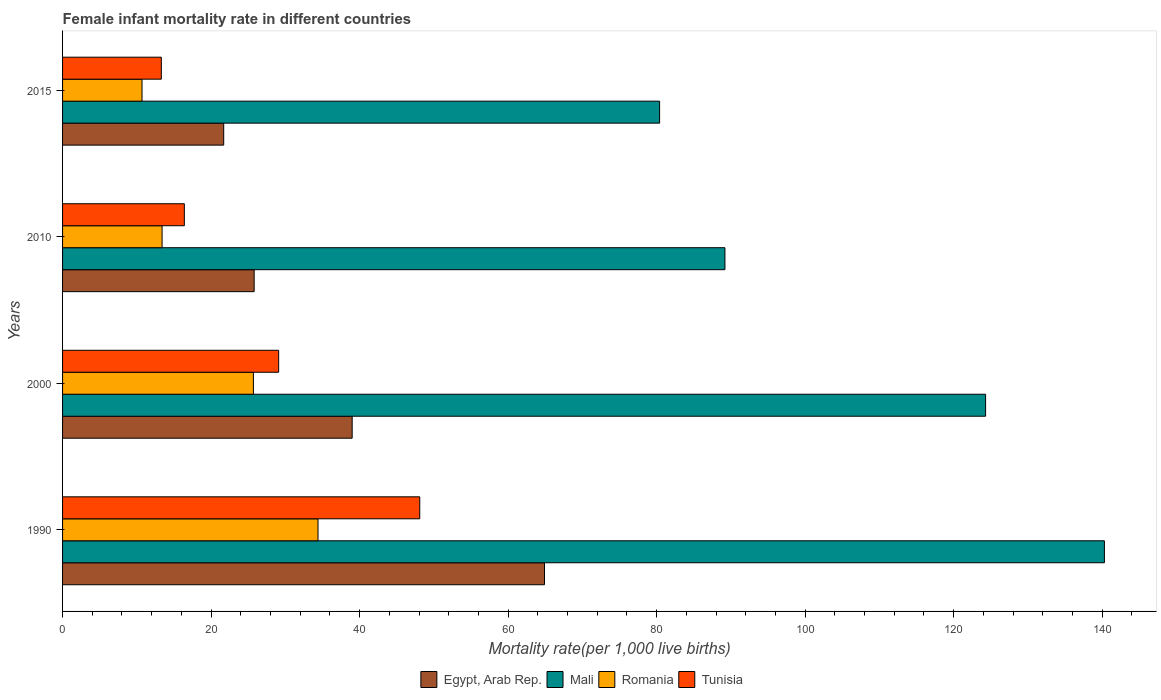How many different coloured bars are there?
Offer a very short reply. 4. How many groups of bars are there?
Your answer should be very brief. 4. Are the number of bars per tick equal to the number of legend labels?
Offer a terse response. Yes. Are the number of bars on each tick of the Y-axis equal?
Offer a very short reply. Yes. How many bars are there on the 4th tick from the top?
Provide a short and direct response. 4. How many bars are there on the 2nd tick from the bottom?
Offer a terse response. 4. What is the female infant mortality rate in Egypt, Arab Rep. in 2015?
Ensure brevity in your answer.  21.7. Across all years, what is the maximum female infant mortality rate in Egypt, Arab Rep.?
Provide a short and direct response. 64.9. Across all years, what is the minimum female infant mortality rate in Egypt, Arab Rep.?
Your answer should be very brief. 21.7. In which year was the female infant mortality rate in Romania maximum?
Offer a very short reply. 1990. In which year was the female infant mortality rate in Mali minimum?
Offer a terse response. 2015. What is the total female infant mortality rate in Egypt, Arab Rep. in the graph?
Offer a terse response. 151.4. What is the difference between the female infant mortality rate in Romania in 2010 and the female infant mortality rate in Egypt, Arab Rep. in 2015?
Keep it short and to the point. -8.3. What is the average female infant mortality rate in Romania per year?
Offer a very short reply. 21.05. What is the ratio of the female infant mortality rate in Mali in 1990 to that in 2000?
Ensure brevity in your answer.  1.13. Is the difference between the female infant mortality rate in Romania in 1990 and 2000 greater than the difference between the female infant mortality rate in Egypt, Arab Rep. in 1990 and 2000?
Offer a terse response. No. What is the difference between the highest and the second highest female infant mortality rate in Egypt, Arab Rep.?
Make the answer very short. 25.9. What is the difference between the highest and the lowest female infant mortality rate in Tunisia?
Ensure brevity in your answer.  34.8. Is the sum of the female infant mortality rate in Romania in 2000 and 2010 greater than the maximum female infant mortality rate in Egypt, Arab Rep. across all years?
Keep it short and to the point. No. Is it the case that in every year, the sum of the female infant mortality rate in Tunisia and female infant mortality rate in Romania is greater than the sum of female infant mortality rate in Mali and female infant mortality rate in Egypt, Arab Rep.?
Provide a succinct answer. No. What does the 2nd bar from the top in 2015 represents?
Your response must be concise. Romania. What does the 1st bar from the bottom in 2000 represents?
Keep it short and to the point. Egypt, Arab Rep. Is it the case that in every year, the sum of the female infant mortality rate in Mali and female infant mortality rate in Romania is greater than the female infant mortality rate in Tunisia?
Make the answer very short. Yes. How many years are there in the graph?
Your response must be concise. 4. What is the difference between two consecutive major ticks on the X-axis?
Provide a succinct answer. 20. Are the values on the major ticks of X-axis written in scientific E-notation?
Offer a very short reply. No. Does the graph contain any zero values?
Your answer should be very brief. No. How many legend labels are there?
Provide a succinct answer. 4. What is the title of the graph?
Provide a short and direct response. Female infant mortality rate in different countries. Does "Bangladesh" appear as one of the legend labels in the graph?
Ensure brevity in your answer.  No. What is the label or title of the X-axis?
Your answer should be very brief. Mortality rate(per 1,0 live births). What is the label or title of the Y-axis?
Make the answer very short. Years. What is the Mortality rate(per 1,000 live births) in Egypt, Arab Rep. in 1990?
Provide a short and direct response. 64.9. What is the Mortality rate(per 1,000 live births) of Mali in 1990?
Provide a short and direct response. 140.3. What is the Mortality rate(per 1,000 live births) of Romania in 1990?
Make the answer very short. 34.4. What is the Mortality rate(per 1,000 live births) in Tunisia in 1990?
Provide a succinct answer. 48.1. What is the Mortality rate(per 1,000 live births) in Egypt, Arab Rep. in 2000?
Offer a very short reply. 39. What is the Mortality rate(per 1,000 live births) in Mali in 2000?
Offer a very short reply. 124.3. What is the Mortality rate(per 1,000 live births) in Romania in 2000?
Provide a succinct answer. 25.7. What is the Mortality rate(per 1,000 live births) of Tunisia in 2000?
Give a very brief answer. 29.1. What is the Mortality rate(per 1,000 live births) of Egypt, Arab Rep. in 2010?
Offer a terse response. 25.8. What is the Mortality rate(per 1,000 live births) of Mali in 2010?
Keep it short and to the point. 89.2. What is the Mortality rate(per 1,000 live births) in Tunisia in 2010?
Provide a short and direct response. 16.4. What is the Mortality rate(per 1,000 live births) in Egypt, Arab Rep. in 2015?
Provide a short and direct response. 21.7. What is the Mortality rate(per 1,000 live births) in Mali in 2015?
Provide a succinct answer. 80.4. Across all years, what is the maximum Mortality rate(per 1,000 live births) in Egypt, Arab Rep.?
Your answer should be very brief. 64.9. Across all years, what is the maximum Mortality rate(per 1,000 live births) of Mali?
Ensure brevity in your answer.  140.3. Across all years, what is the maximum Mortality rate(per 1,000 live births) of Romania?
Ensure brevity in your answer.  34.4. Across all years, what is the maximum Mortality rate(per 1,000 live births) of Tunisia?
Your response must be concise. 48.1. Across all years, what is the minimum Mortality rate(per 1,000 live births) in Egypt, Arab Rep.?
Your answer should be very brief. 21.7. Across all years, what is the minimum Mortality rate(per 1,000 live births) in Mali?
Your answer should be compact. 80.4. Across all years, what is the minimum Mortality rate(per 1,000 live births) in Romania?
Keep it short and to the point. 10.7. What is the total Mortality rate(per 1,000 live births) of Egypt, Arab Rep. in the graph?
Make the answer very short. 151.4. What is the total Mortality rate(per 1,000 live births) of Mali in the graph?
Give a very brief answer. 434.2. What is the total Mortality rate(per 1,000 live births) in Romania in the graph?
Ensure brevity in your answer.  84.2. What is the total Mortality rate(per 1,000 live births) of Tunisia in the graph?
Provide a succinct answer. 106.9. What is the difference between the Mortality rate(per 1,000 live births) in Egypt, Arab Rep. in 1990 and that in 2000?
Give a very brief answer. 25.9. What is the difference between the Mortality rate(per 1,000 live births) of Mali in 1990 and that in 2000?
Your answer should be very brief. 16. What is the difference between the Mortality rate(per 1,000 live births) in Tunisia in 1990 and that in 2000?
Keep it short and to the point. 19. What is the difference between the Mortality rate(per 1,000 live births) of Egypt, Arab Rep. in 1990 and that in 2010?
Offer a terse response. 39.1. What is the difference between the Mortality rate(per 1,000 live births) in Mali in 1990 and that in 2010?
Offer a very short reply. 51.1. What is the difference between the Mortality rate(per 1,000 live births) of Romania in 1990 and that in 2010?
Give a very brief answer. 21. What is the difference between the Mortality rate(per 1,000 live births) of Tunisia in 1990 and that in 2010?
Your answer should be very brief. 31.7. What is the difference between the Mortality rate(per 1,000 live births) of Egypt, Arab Rep. in 1990 and that in 2015?
Your answer should be compact. 43.2. What is the difference between the Mortality rate(per 1,000 live births) in Mali in 1990 and that in 2015?
Make the answer very short. 59.9. What is the difference between the Mortality rate(per 1,000 live births) in Romania in 1990 and that in 2015?
Keep it short and to the point. 23.7. What is the difference between the Mortality rate(per 1,000 live births) of Tunisia in 1990 and that in 2015?
Ensure brevity in your answer.  34.8. What is the difference between the Mortality rate(per 1,000 live births) in Mali in 2000 and that in 2010?
Provide a succinct answer. 35.1. What is the difference between the Mortality rate(per 1,000 live births) in Romania in 2000 and that in 2010?
Offer a terse response. 12.3. What is the difference between the Mortality rate(per 1,000 live births) in Tunisia in 2000 and that in 2010?
Keep it short and to the point. 12.7. What is the difference between the Mortality rate(per 1,000 live births) in Egypt, Arab Rep. in 2000 and that in 2015?
Your answer should be very brief. 17.3. What is the difference between the Mortality rate(per 1,000 live births) of Mali in 2000 and that in 2015?
Provide a succinct answer. 43.9. What is the difference between the Mortality rate(per 1,000 live births) in Tunisia in 2000 and that in 2015?
Your answer should be compact. 15.8. What is the difference between the Mortality rate(per 1,000 live births) of Egypt, Arab Rep. in 2010 and that in 2015?
Offer a terse response. 4.1. What is the difference between the Mortality rate(per 1,000 live births) of Egypt, Arab Rep. in 1990 and the Mortality rate(per 1,000 live births) of Mali in 2000?
Offer a very short reply. -59.4. What is the difference between the Mortality rate(per 1,000 live births) of Egypt, Arab Rep. in 1990 and the Mortality rate(per 1,000 live births) of Romania in 2000?
Keep it short and to the point. 39.2. What is the difference between the Mortality rate(per 1,000 live births) of Egypt, Arab Rep. in 1990 and the Mortality rate(per 1,000 live births) of Tunisia in 2000?
Provide a succinct answer. 35.8. What is the difference between the Mortality rate(per 1,000 live births) of Mali in 1990 and the Mortality rate(per 1,000 live births) of Romania in 2000?
Provide a short and direct response. 114.6. What is the difference between the Mortality rate(per 1,000 live births) of Mali in 1990 and the Mortality rate(per 1,000 live births) of Tunisia in 2000?
Make the answer very short. 111.2. What is the difference between the Mortality rate(per 1,000 live births) of Egypt, Arab Rep. in 1990 and the Mortality rate(per 1,000 live births) of Mali in 2010?
Make the answer very short. -24.3. What is the difference between the Mortality rate(per 1,000 live births) in Egypt, Arab Rep. in 1990 and the Mortality rate(per 1,000 live births) in Romania in 2010?
Provide a short and direct response. 51.5. What is the difference between the Mortality rate(per 1,000 live births) of Egypt, Arab Rep. in 1990 and the Mortality rate(per 1,000 live births) of Tunisia in 2010?
Ensure brevity in your answer.  48.5. What is the difference between the Mortality rate(per 1,000 live births) in Mali in 1990 and the Mortality rate(per 1,000 live births) in Romania in 2010?
Provide a short and direct response. 126.9. What is the difference between the Mortality rate(per 1,000 live births) in Mali in 1990 and the Mortality rate(per 1,000 live births) in Tunisia in 2010?
Keep it short and to the point. 123.9. What is the difference between the Mortality rate(per 1,000 live births) in Egypt, Arab Rep. in 1990 and the Mortality rate(per 1,000 live births) in Mali in 2015?
Ensure brevity in your answer.  -15.5. What is the difference between the Mortality rate(per 1,000 live births) in Egypt, Arab Rep. in 1990 and the Mortality rate(per 1,000 live births) in Romania in 2015?
Make the answer very short. 54.2. What is the difference between the Mortality rate(per 1,000 live births) in Egypt, Arab Rep. in 1990 and the Mortality rate(per 1,000 live births) in Tunisia in 2015?
Offer a terse response. 51.6. What is the difference between the Mortality rate(per 1,000 live births) of Mali in 1990 and the Mortality rate(per 1,000 live births) of Romania in 2015?
Offer a very short reply. 129.6. What is the difference between the Mortality rate(per 1,000 live births) of Mali in 1990 and the Mortality rate(per 1,000 live births) of Tunisia in 2015?
Provide a short and direct response. 127. What is the difference between the Mortality rate(per 1,000 live births) in Romania in 1990 and the Mortality rate(per 1,000 live births) in Tunisia in 2015?
Offer a terse response. 21.1. What is the difference between the Mortality rate(per 1,000 live births) in Egypt, Arab Rep. in 2000 and the Mortality rate(per 1,000 live births) in Mali in 2010?
Ensure brevity in your answer.  -50.2. What is the difference between the Mortality rate(per 1,000 live births) of Egypt, Arab Rep. in 2000 and the Mortality rate(per 1,000 live births) of Romania in 2010?
Your answer should be compact. 25.6. What is the difference between the Mortality rate(per 1,000 live births) of Egypt, Arab Rep. in 2000 and the Mortality rate(per 1,000 live births) of Tunisia in 2010?
Your answer should be very brief. 22.6. What is the difference between the Mortality rate(per 1,000 live births) of Mali in 2000 and the Mortality rate(per 1,000 live births) of Romania in 2010?
Provide a succinct answer. 110.9. What is the difference between the Mortality rate(per 1,000 live births) in Mali in 2000 and the Mortality rate(per 1,000 live births) in Tunisia in 2010?
Your response must be concise. 107.9. What is the difference between the Mortality rate(per 1,000 live births) of Romania in 2000 and the Mortality rate(per 1,000 live births) of Tunisia in 2010?
Your answer should be very brief. 9.3. What is the difference between the Mortality rate(per 1,000 live births) of Egypt, Arab Rep. in 2000 and the Mortality rate(per 1,000 live births) of Mali in 2015?
Offer a terse response. -41.4. What is the difference between the Mortality rate(per 1,000 live births) in Egypt, Arab Rep. in 2000 and the Mortality rate(per 1,000 live births) in Romania in 2015?
Offer a very short reply. 28.3. What is the difference between the Mortality rate(per 1,000 live births) of Egypt, Arab Rep. in 2000 and the Mortality rate(per 1,000 live births) of Tunisia in 2015?
Provide a succinct answer. 25.7. What is the difference between the Mortality rate(per 1,000 live births) in Mali in 2000 and the Mortality rate(per 1,000 live births) in Romania in 2015?
Offer a very short reply. 113.6. What is the difference between the Mortality rate(per 1,000 live births) of Mali in 2000 and the Mortality rate(per 1,000 live births) of Tunisia in 2015?
Make the answer very short. 111. What is the difference between the Mortality rate(per 1,000 live births) of Romania in 2000 and the Mortality rate(per 1,000 live births) of Tunisia in 2015?
Provide a succinct answer. 12.4. What is the difference between the Mortality rate(per 1,000 live births) in Egypt, Arab Rep. in 2010 and the Mortality rate(per 1,000 live births) in Mali in 2015?
Your response must be concise. -54.6. What is the difference between the Mortality rate(per 1,000 live births) of Egypt, Arab Rep. in 2010 and the Mortality rate(per 1,000 live births) of Romania in 2015?
Provide a short and direct response. 15.1. What is the difference between the Mortality rate(per 1,000 live births) of Egypt, Arab Rep. in 2010 and the Mortality rate(per 1,000 live births) of Tunisia in 2015?
Your response must be concise. 12.5. What is the difference between the Mortality rate(per 1,000 live births) of Mali in 2010 and the Mortality rate(per 1,000 live births) of Romania in 2015?
Your answer should be very brief. 78.5. What is the difference between the Mortality rate(per 1,000 live births) of Mali in 2010 and the Mortality rate(per 1,000 live births) of Tunisia in 2015?
Give a very brief answer. 75.9. What is the average Mortality rate(per 1,000 live births) in Egypt, Arab Rep. per year?
Give a very brief answer. 37.85. What is the average Mortality rate(per 1,000 live births) in Mali per year?
Provide a short and direct response. 108.55. What is the average Mortality rate(per 1,000 live births) in Romania per year?
Make the answer very short. 21.05. What is the average Mortality rate(per 1,000 live births) of Tunisia per year?
Ensure brevity in your answer.  26.73. In the year 1990, what is the difference between the Mortality rate(per 1,000 live births) in Egypt, Arab Rep. and Mortality rate(per 1,000 live births) in Mali?
Offer a terse response. -75.4. In the year 1990, what is the difference between the Mortality rate(per 1,000 live births) in Egypt, Arab Rep. and Mortality rate(per 1,000 live births) in Romania?
Provide a short and direct response. 30.5. In the year 1990, what is the difference between the Mortality rate(per 1,000 live births) of Egypt, Arab Rep. and Mortality rate(per 1,000 live births) of Tunisia?
Keep it short and to the point. 16.8. In the year 1990, what is the difference between the Mortality rate(per 1,000 live births) in Mali and Mortality rate(per 1,000 live births) in Romania?
Keep it short and to the point. 105.9. In the year 1990, what is the difference between the Mortality rate(per 1,000 live births) in Mali and Mortality rate(per 1,000 live births) in Tunisia?
Provide a succinct answer. 92.2. In the year 1990, what is the difference between the Mortality rate(per 1,000 live births) in Romania and Mortality rate(per 1,000 live births) in Tunisia?
Provide a succinct answer. -13.7. In the year 2000, what is the difference between the Mortality rate(per 1,000 live births) in Egypt, Arab Rep. and Mortality rate(per 1,000 live births) in Mali?
Ensure brevity in your answer.  -85.3. In the year 2000, what is the difference between the Mortality rate(per 1,000 live births) in Egypt, Arab Rep. and Mortality rate(per 1,000 live births) in Romania?
Your answer should be very brief. 13.3. In the year 2000, what is the difference between the Mortality rate(per 1,000 live births) in Egypt, Arab Rep. and Mortality rate(per 1,000 live births) in Tunisia?
Offer a very short reply. 9.9. In the year 2000, what is the difference between the Mortality rate(per 1,000 live births) of Mali and Mortality rate(per 1,000 live births) of Romania?
Provide a succinct answer. 98.6. In the year 2000, what is the difference between the Mortality rate(per 1,000 live births) of Mali and Mortality rate(per 1,000 live births) of Tunisia?
Provide a short and direct response. 95.2. In the year 2010, what is the difference between the Mortality rate(per 1,000 live births) of Egypt, Arab Rep. and Mortality rate(per 1,000 live births) of Mali?
Provide a succinct answer. -63.4. In the year 2010, what is the difference between the Mortality rate(per 1,000 live births) of Egypt, Arab Rep. and Mortality rate(per 1,000 live births) of Romania?
Keep it short and to the point. 12.4. In the year 2010, what is the difference between the Mortality rate(per 1,000 live births) in Egypt, Arab Rep. and Mortality rate(per 1,000 live births) in Tunisia?
Make the answer very short. 9.4. In the year 2010, what is the difference between the Mortality rate(per 1,000 live births) of Mali and Mortality rate(per 1,000 live births) of Romania?
Your response must be concise. 75.8. In the year 2010, what is the difference between the Mortality rate(per 1,000 live births) of Mali and Mortality rate(per 1,000 live births) of Tunisia?
Your answer should be very brief. 72.8. In the year 2015, what is the difference between the Mortality rate(per 1,000 live births) of Egypt, Arab Rep. and Mortality rate(per 1,000 live births) of Mali?
Offer a terse response. -58.7. In the year 2015, what is the difference between the Mortality rate(per 1,000 live births) of Egypt, Arab Rep. and Mortality rate(per 1,000 live births) of Romania?
Offer a very short reply. 11. In the year 2015, what is the difference between the Mortality rate(per 1,000 live births) in Mali and Mortality rate(per 1,000 live births) in Romania?
Ensure brevity in your answer.  69.7. In the year 2015, what is the difference between the Mortality rate(per 1,000 live births) of Mali and Mortality rate(per 1,000 live births) of Tunisia?
Your answer should be compact. 67.1. What is the ratio of the Mortality rate(per 1,000 live births) of Egypt, Arab Rep. in 1990 to that in 2000?
Provide a short and direct response. 1.66. What is the ratio of the Mortality rate(per 1,000 live births) in Mali in 1990 to that in 2000?
Give a very brief answer. 1.13. What is the ratio of the Mortality rate(per 1,000 live births) in Romania in 1990 to that in 2000?
Your answer should be compact. 1.34. What is the ratio of the Mortality rate(per 1,000 live births) of Tunisia in 1990 to that in 2000?
Keep it short and to the point. 1.65. What is the ratio of the Mortality rate(per 1,000 live births) of Egypt, Arab Rep. in 1990 to that in 2010?
Your answer should be very brief. 2.52. What is the ratio of the Mortality rate(per 1,000 live births) of Mali in 1990 to that in 2010?
Keep it short and to the point. 1.57. What is the ratio of the Mortality rate(per 1,000 live births) of Romania in 1990 to that in 2010?
Your answer should be compact. 2.57. What is the ratio of the Mortality rate(per 1,000 live births) in Tunisia in 1990 to that in 2010?
Provide a succinct answer. 2.93. What is the ratio of the Mortality rate(per 1,000 live births) of Egypt, Arab Rep. in 1990 to that in 2015?
Offer a very short reply. 2.99. What is the ratio of the Mortality rate(per 1,000 live births) in Mali in 1990 to that in 2015?
Your answer should be compact. 1.75. What is the ratio of the Mortality rate(per 1,000 live births) in Romania in 1990 to that in 2015?
Offer a terse response. 3.21. What is the ratio of the Mortality rate(per 1,000 live births) in Tunisia in 1990 to that in 2015?
Make the answer very short. 3.62. What is the ratio of the Mortality rate(per 1,000 live births) of Egypt, Arab Rep. in 2000 to that in 2010?
Your response must be concise. 1.51. What is the ratio of the Mortality rate(per 1,000 live births) in Mali in 2000 to that in 2010?
Keep it short and to the point. 1.39. What is the ratio of the Mortality rate(per 1,000 live births) in Romania in 2000 to that in 2010?
Provide a succinct answer. 1.92. What is the ratio of the Mortality rate(per 1,000 live births) in Tunisia in 2000 to that in 2010?
Provide a short and direct response. 1.77. What is the ratio of the Mortality rate(per 1,000 live births) in Egypt, Arab Rep. in 2000 to that in 2015?
Keep it short and to the point. 1.8. What is the ratio of the Mortality rate(per 1,000 live births) in Mali in 2000 to that in 2015?
Your answer should be very brief. 1.55. What is the ratio of the Mortality rate(per 1,000 live births) in Romania in 2000 to that in 2015?
Your response must be concise. 2.4. What is the ratio of the Mortality rate(per 1,000 live births) in Tunisia in 2000 to that in 2015?
Offer a very short reply. 2.19. What is the ratio of the Mortality rate(per 1,000 live births) in Egypt, Arab Rep. in 2010 to that in 2015?
Offer a very short reply. 1.19. What is the ratio of the Mortality rate(per 1,000 live births) of Mali in 2010 to that in 2015?
Provide a short and direct response. 1.11. What is the ratio of the Mortality rate(per 1,000 live births) of Romania in 2010 to that in 2015?
Provide a succinct answer. 1.25. What is the ratio of the Mortality rate(per 1,000 live births) in Tunisia in 2010 to that in 2015?
Offer a very short reply. 1.23. What is the difference between the highest and the second highest Mortality rate(per 1,000 live births) of Egypt, Arab Rep.?
Provide a succinct answer. 25.9. What is the difference between the highest and the second highest Mortality rate(per 1,000 live births) in Mali?
Keep it short and to the point. 16. What is the difference between the highest and the second highest Mortality rate(per 1,000 live births) in Romania?
Keep it short and to the point. 8.7. What is the difference between the highest and the second highest Mortality rate(per 1,000 live births) of Tunisia?
Your response must be concise. 19. What is the difference between the highest and the lowest Mortality rate(per 1,000 live births) in Egypt, Arab Rep.?
Provide a succinct answer. 43.2. What is the difference between the highest and the lowest Mortality rate(per 1,000 live births) in Mali?
Keep it short and to the point. 59.9. What is the difference between the highest and the lowest Mortality rate(per 1,000 live births) of Romania?
Give a very brief answer. 23.7. What is the difference between the highest and the lowest Mortality rate(per 1,000 live births) of Tunisia?
Ensure brevity in your answer.  34.8. 